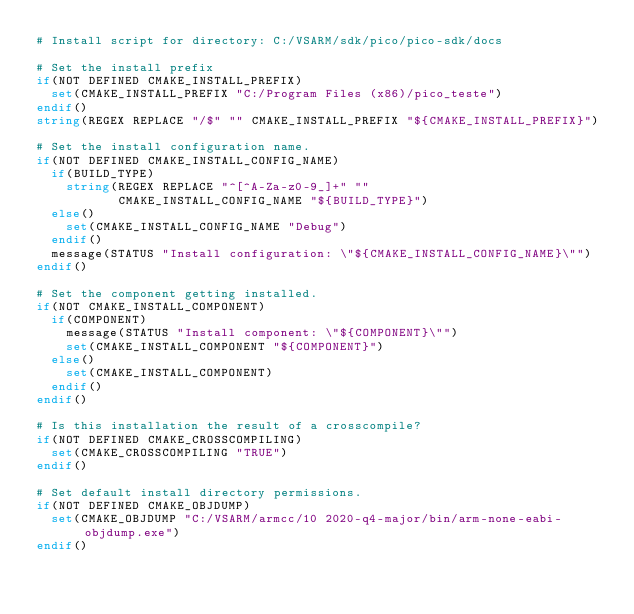Convert code to text. <code><loc_0><loc_0><loc_500><loc_500><_CMake_># Install script for directory: C:/VSARM/sdk/pico/pico-sdk/docs

# Set the install prefix
if(NOT DEFINED CMAKE_INSTALL_PREFIX)
  set(CMAKE_INSTALL_PREFIX "C:/Program Files (x86)/pico_teste")
endif()
string(REGEX REPLACE "/$" "" CMAKE_INSTALL_PREFIX "${CMAKE_INSTALL_PREFIX}")

# Set the install configuration name.
if(NOT DEFINED CMAKE_INSTALL_CONFIG_NAME)
  if(BUILD_TYPE)
    string(REGEX REPLACE "^[^A-Za-z0-9_]+" ""
           CMAKE_INSTALL_CONFIG_NAME "${BUILD_TYPE}")
  else()
    set(CMAKE_INSTALL_CONFIG_NAME "Debug")
  endif()
  message(STATUS "Install configuration: \"${CMAKE_INSTALL_CONFIG_NAME}\"")
endif()

# Set the component getting installed.
if(NOT CMAKE_INSTALL_COMPONENT)
  if(COMPONENT)
    message(STATUS "Install component: \"${COMPONENT}\"")
    set(CMAKE_INSTALL_COMPONENT "${COMPONENT}")
  else()
    set(CMAKE_INSTALL_COMPONENT)
  endif()
endif()

# Is this installation the result of a crosscompile?
if(NOT DEFINED CMAKE_CROSSCOMPILING)
  set(CMAKE_CROSSCOMPILING "TRUE")
endif()

# Set default install directory permissions.
if(NOT DEFINED CMAKE_OBJDUMP)
  set(CMAKE_OBJDUMP "C:/VSARM/armcc/10 2020-q4-major/bin/arm-none-eabi-objdump.exe")
endif()

</code> 